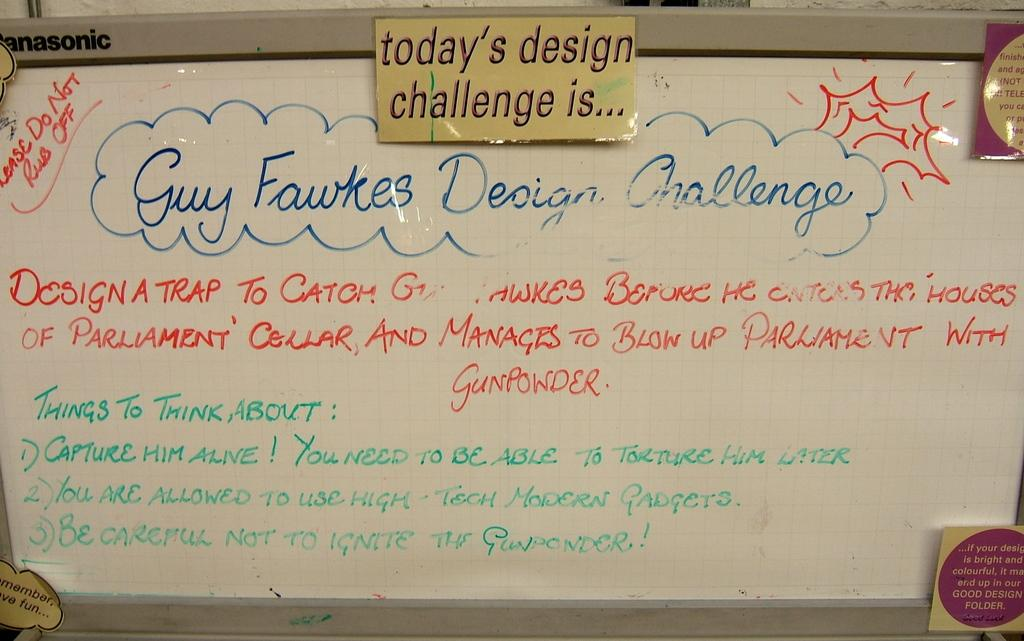<image>
Offer a succinct explanation of the picture presented. A white dry erase board with a daily challenge and thoughts for the day written on it. 